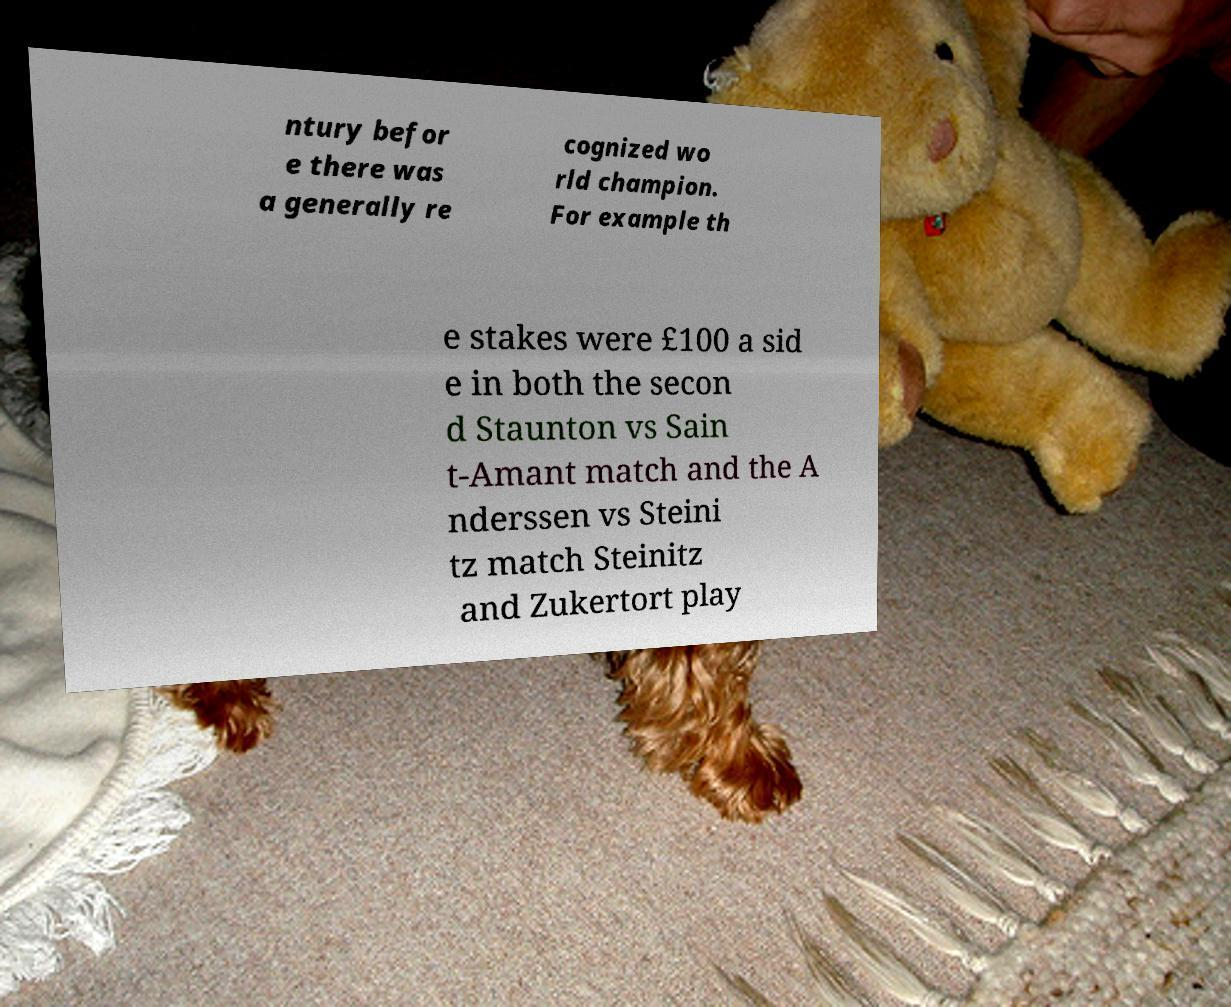Can you accurately transcribe the text from the provided image for me? ntury befor e there was a generally re cognized wo rld champion. For example th e stakes were £100 a sid e in both the secon d Staunton vs Sain t-Amant match and the A nderssen vs Steini tz match Steinitz and Zukertort play 